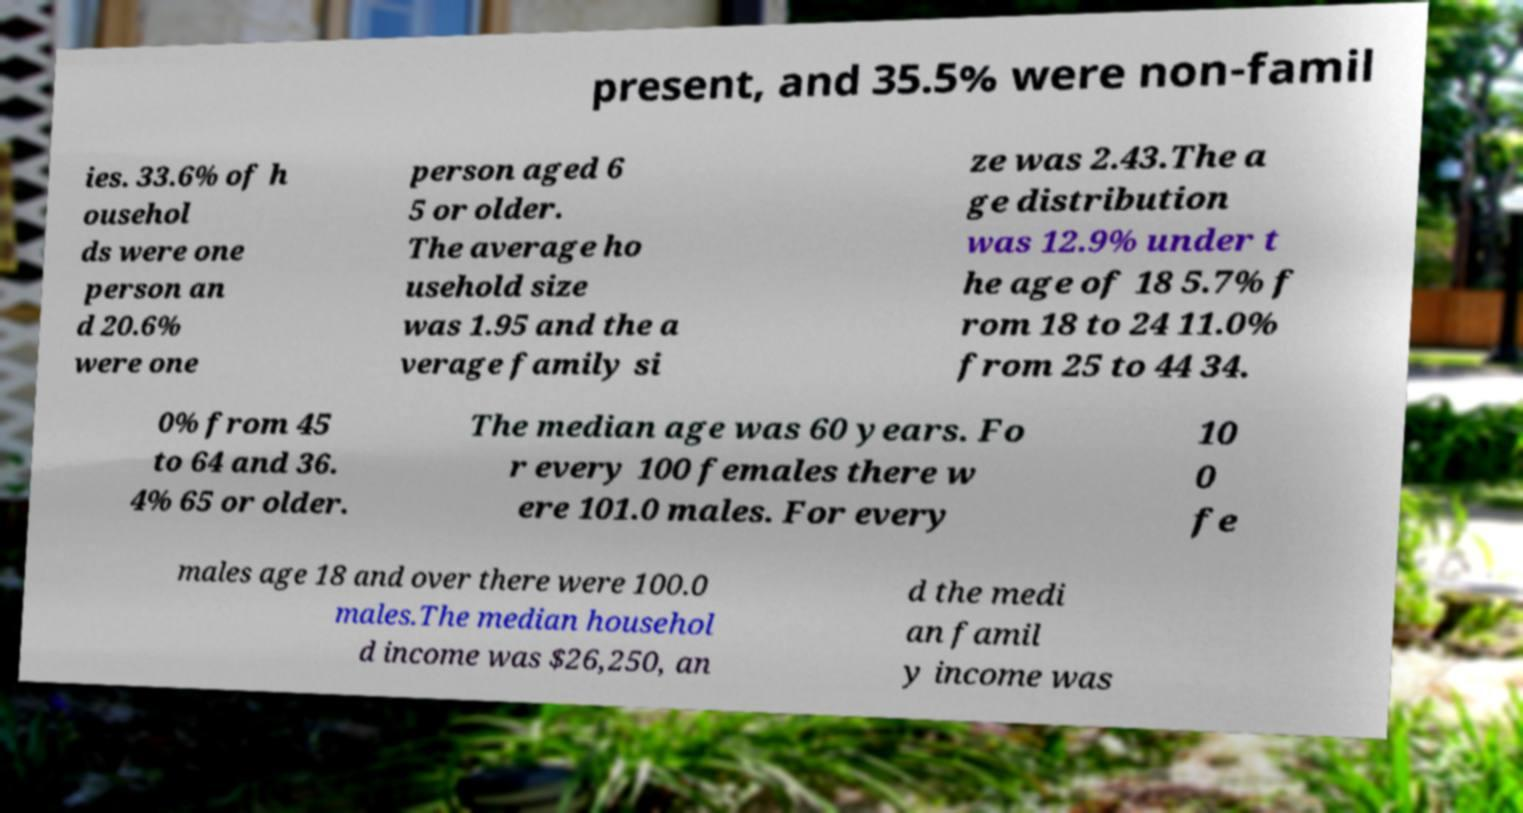Please identify and transcribe the text found in this image. present, and 35.5% were non-famil ies. 33.6% of h ousehol ds were one person an d 20.6% were one person aged 6 5 or older. The average ho usehold size was 1.95 and the a verage family si ze was 2.43.The a ge distribution was 12.9% under t he age of 18 5.7% f rom 18 to 24 11.0% from 25 to 44 34. 0% from 45 to 64 and 36. 4% 65 or older. The median age was 60 years. Fo r every 100 females there w ere 101.0 males. For every 10 0 fe males age 18 and over there were 100.0 males.The median househol d income was $26,250, an d the medi an famil y income was 